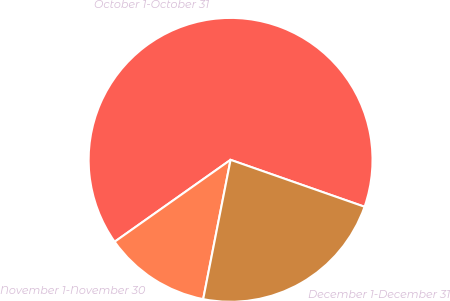<chart> <loc_0><loc_0><loc_500><loc_500><pie_chart><fcel>October 1-October 31<fcel>November 1-November 30<fcel>December 1-December 31<nl><fcel>65.15%<fcel>12.12%<fcel>22.73%<nl></chart> 